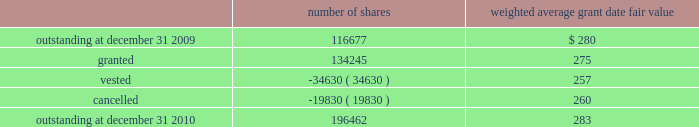The company granted 1020 performance shares .
The vesting of these shares is contingent on meeting stated goals over a performance period .
Beginning with restricted stock grants in september 2010 , dividends are accrued on restricted class a common stock and restricted stock units and are paid once the restricted stock vests .
The table summarizes restricted stock and performance shares activity for 2010 : number of shares weighted average grant date fair value .
The total fair value of restricted stock that vested during the years ended december 31 , 2010 , 2009 and 2008 , was $ 10.3 million , $ 6.2 million and $ 2.5 million , respectively .
Eligible employees may acquire shares of cme group 2019s class a common stock using after-tax payroll deductions made during consecutive offering periods of approximately six months in duration .
Shares are purchased at the end of each offering period at a price of 90% ( 90 % ) of the closing price of the class a common stock as reported on the nasdaq .
Compensation expense is recognized on the dates of purchase for the discount from the closing price .
In 2010 , 2009 and 2008 , a total of 4371 , 4402 and 5600 shares , respectively , of class a common stock were issued to participating employees .
These shares are subject to a six-month holding period .
Annual expense of $ 0.1 million for the purchase discount was recognized in 2010 , 2009 and 2008 , respectively .
Non-executive directors receive an annual award of class a common stock with a value equal to $ 75000 .
Non-executive directors may also elect to receive some or all of the cash portion of their annual stipend , up to $ 25000 , in shares of stock based on the closing price at the date of distribution .
As a result , 7470 , 11674 and 5509 shares of class a common stock were issued to non-executive directors during 2010 , 2009 and 2008 , respectively .
These shares are not subject to any vesting restrictions .
Expense of $ 2.4 million , $ 2.5 million and $ 2.4 million related to these stock-based payments was recognized for the years ended december 31 , 2010 , 2009 and 2008 , respectively. .
What is the performance shares granted as a percent of the total number of granted shares in 2010? 
Rationale: its the number of granted performance shares divided by the total amount of granted shares in the year 2010 .
Computations: (1020 / 134245)
Answer: 0.0076. 